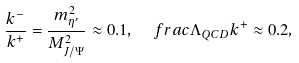<formula> <loc_0><loc_0><loc_500><loc_500>\frac { k ^ { - } } { k ^ { + } } = \frac { m ^ { 2 } _ { \eta ^ { \prime } } } { M _ { J / \Psi } ^ { 2 } } \approx 0 . 1 , \ \ \ f r a c { \Lambda _ { Q C D } } { k ^ { + } } \approx 0 . 2 ,</formula> 